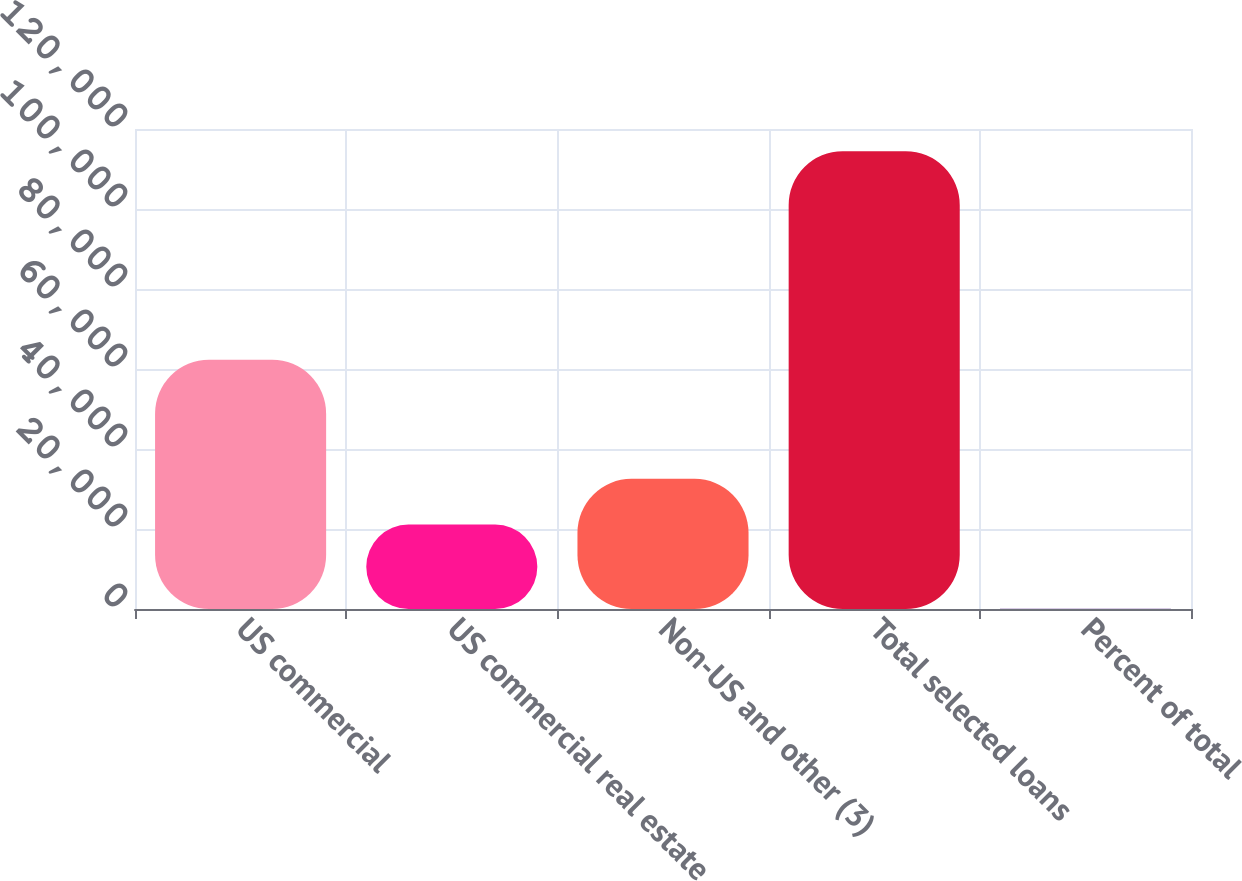<chart> <loc_0><loc_0><loc_500><loc_500><bar_chart><fcel>US commercial<fcel>US commercial real estate<fcel>Non-US and other (3)<fcel>Total selected loans<fcel>Percent of total<nl><fcel>62325<fcel>21097<fcel>32536.3<fcel>114434<fcel>41.4<nl></chart> 